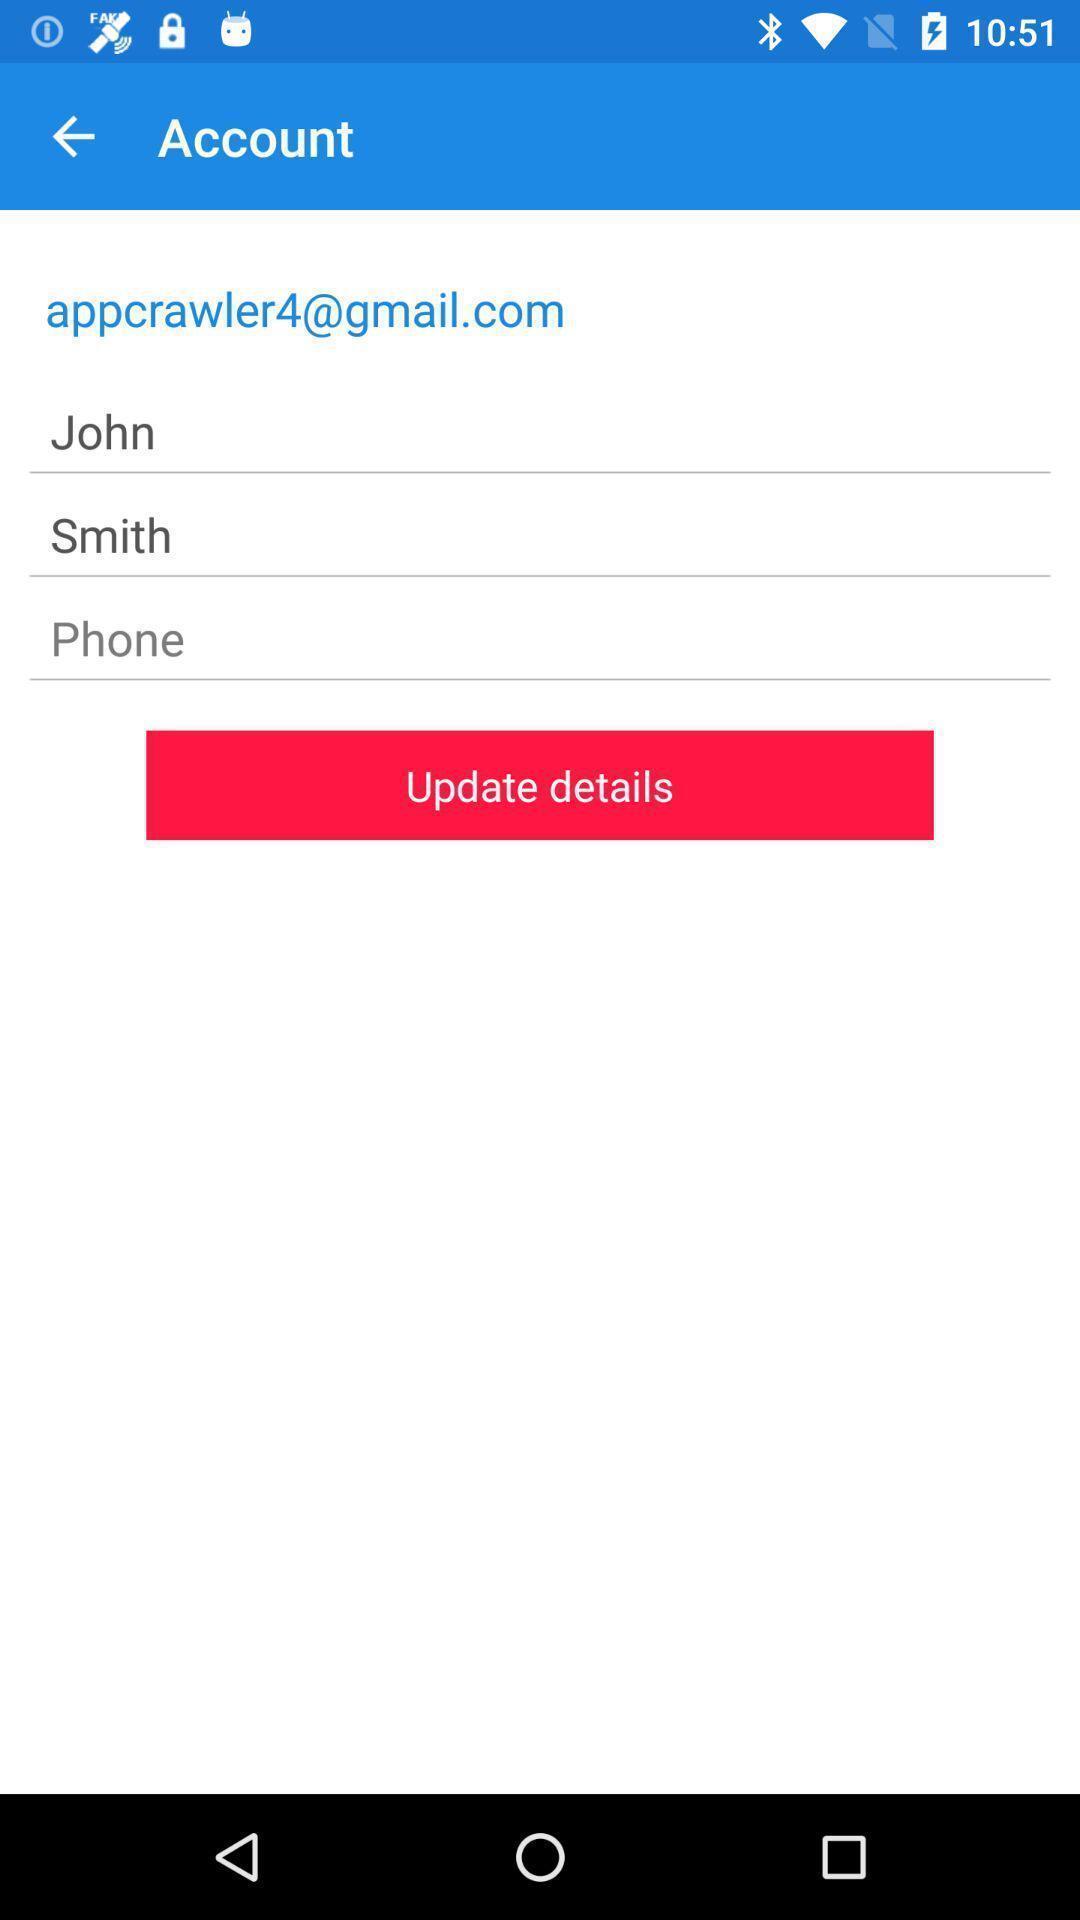Provide a textual representation of this image. Page to update account details. 